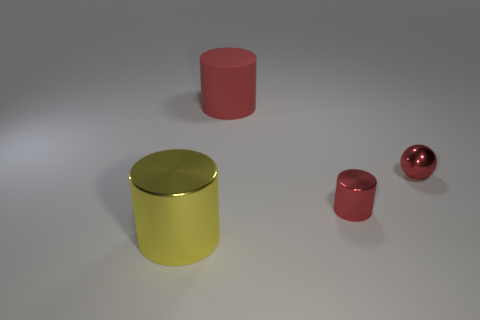What number of tiny cylinders are there?
Your answer should be very brief. 1. There is a small metallic thing behind the tiny red cylinder; how many tiny red metallic things are in front of it?
Your answer should be compact. 1. There is a large rubber object; is its color the same as the metal cylinder that is to the right of the big yellow cylinder?
Provide a short and direct response. Yes. How many other big rubber objects are the same shape as the big red thing?
Provide a succinct answer. 0. There is a large cylinder to the right of the large shiny cylinder; what material is it?
Make the answer very short. Rubber. Is the shape of the big thing in front of the red rubber cylinder the same as  the matte object?
Give a very brief answer. Yes. Is there a red shiny object of the same size as the sphere?
Make the answer very short. Yes. There is a yellow metallic object; does it have the same shape as the red thing left of the tiny red cylinder?
Make the answer very short. Yes. There is a big rubber thing that is the same color as the tiny shiny ball; what is its shape?
Your answer should be compact. Cylinder. Are there fewer big red matte cylinders in front of the large red matte cylinder than large matte things?
Give a very brief answer. Yes. 